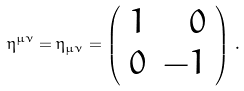<formula> <loc_0><loc_0><loc_500><loc_500>\eta ^ { \mu \nu } = \eta _ { \mu \nu } = \left ( \begin{array} { c r } 1 & { 0 } \\ { 0 } & - { 1 } \end{array} \right ) \, .</formula> 